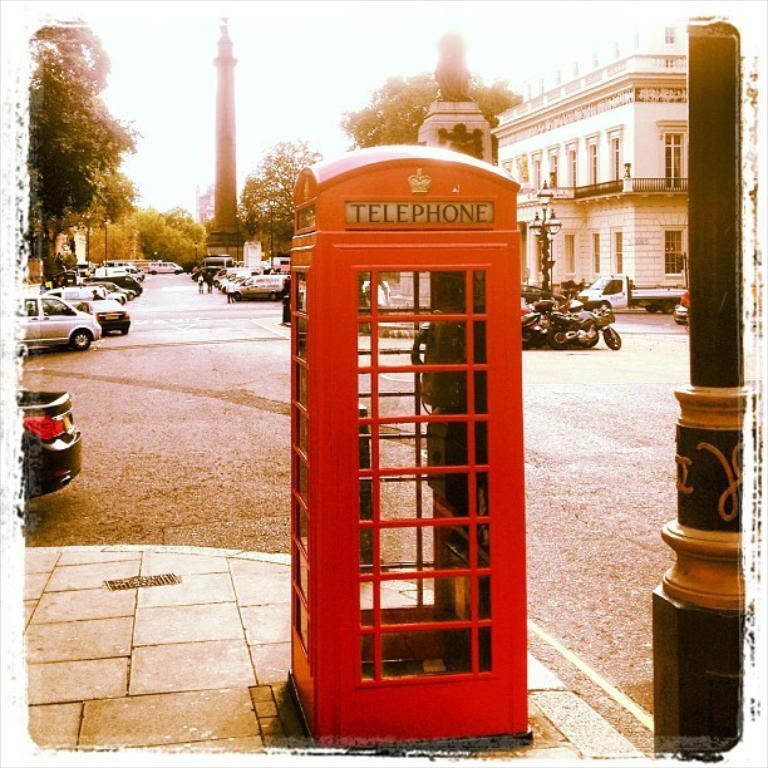Provide a one-sentence caption for the provided image. a telephone booth that is red in color. 